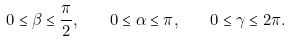<formula> <loc_0><loc_0><loc_500><loc_500>0 \leq \beta \leq \frac { \pi } { 2 } , \quad 0 \leq \alpha \leq \pi , \quad 0 \leq \gamma \leq 2 \pi .</formula> 